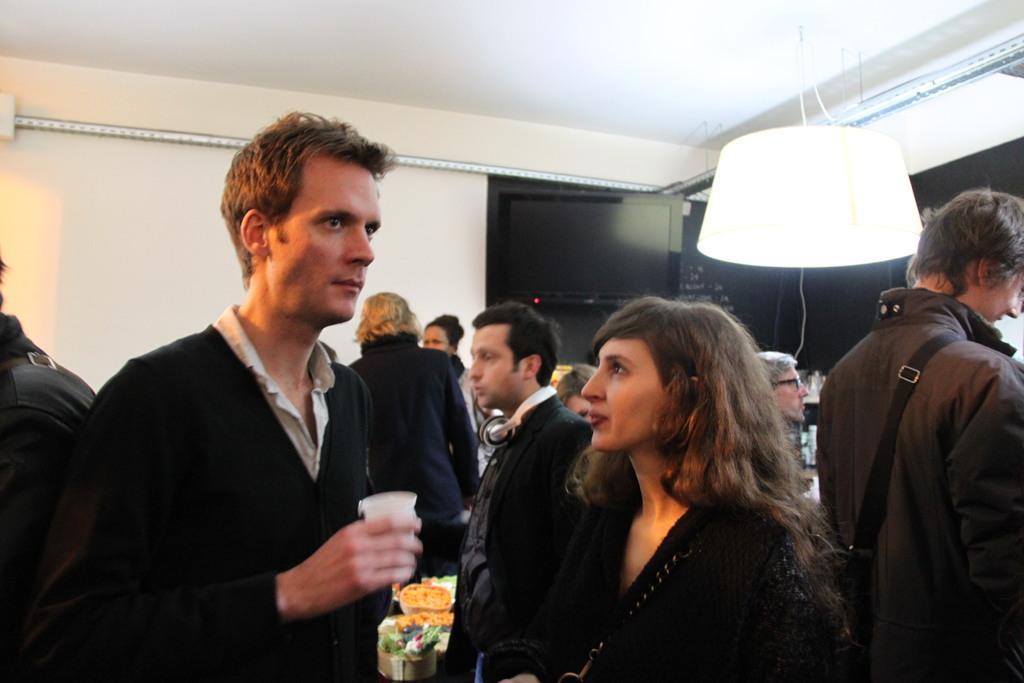How would you summarize this image in a sentence or two? In the center of the image we can see two persons are standing and the man is holding one glass. In the background there is a wall, roof, lamp, few people are standing and few other objects. 